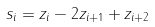Convert formula to latex. <formula><loc_0><loc_0><loc_500><loc_500>s _ { i } = z _ { i } - 2 z _ { i + 1 } + z _ { i + 2 }</formula> 